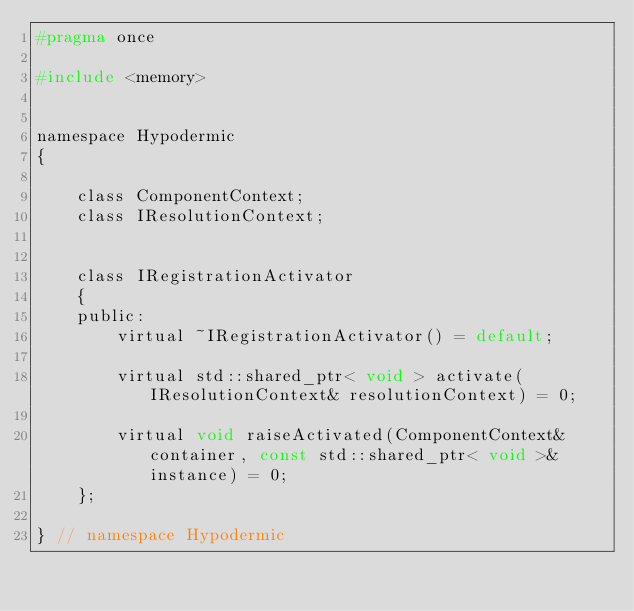<code> <loc_0><loc_0><loc_500><loc_500><_C_>#pragma once

#include <memory>


namespace Hypodermic
{

    class ComponentContext;
    class IResolutionContext;


    class IRegistrationActivator
    {
    public:
        virtual ~IRegistrationActivator() = default;

        virtual std::shared_ptr< void > activate(IResolutionContext& resolutionContext) = 0;

        virtual void raiseActivated(ComponentContext& container, const std::shared_ptr< void >& instance) = 0;
    };

} // namespace Hypodermic</code> 